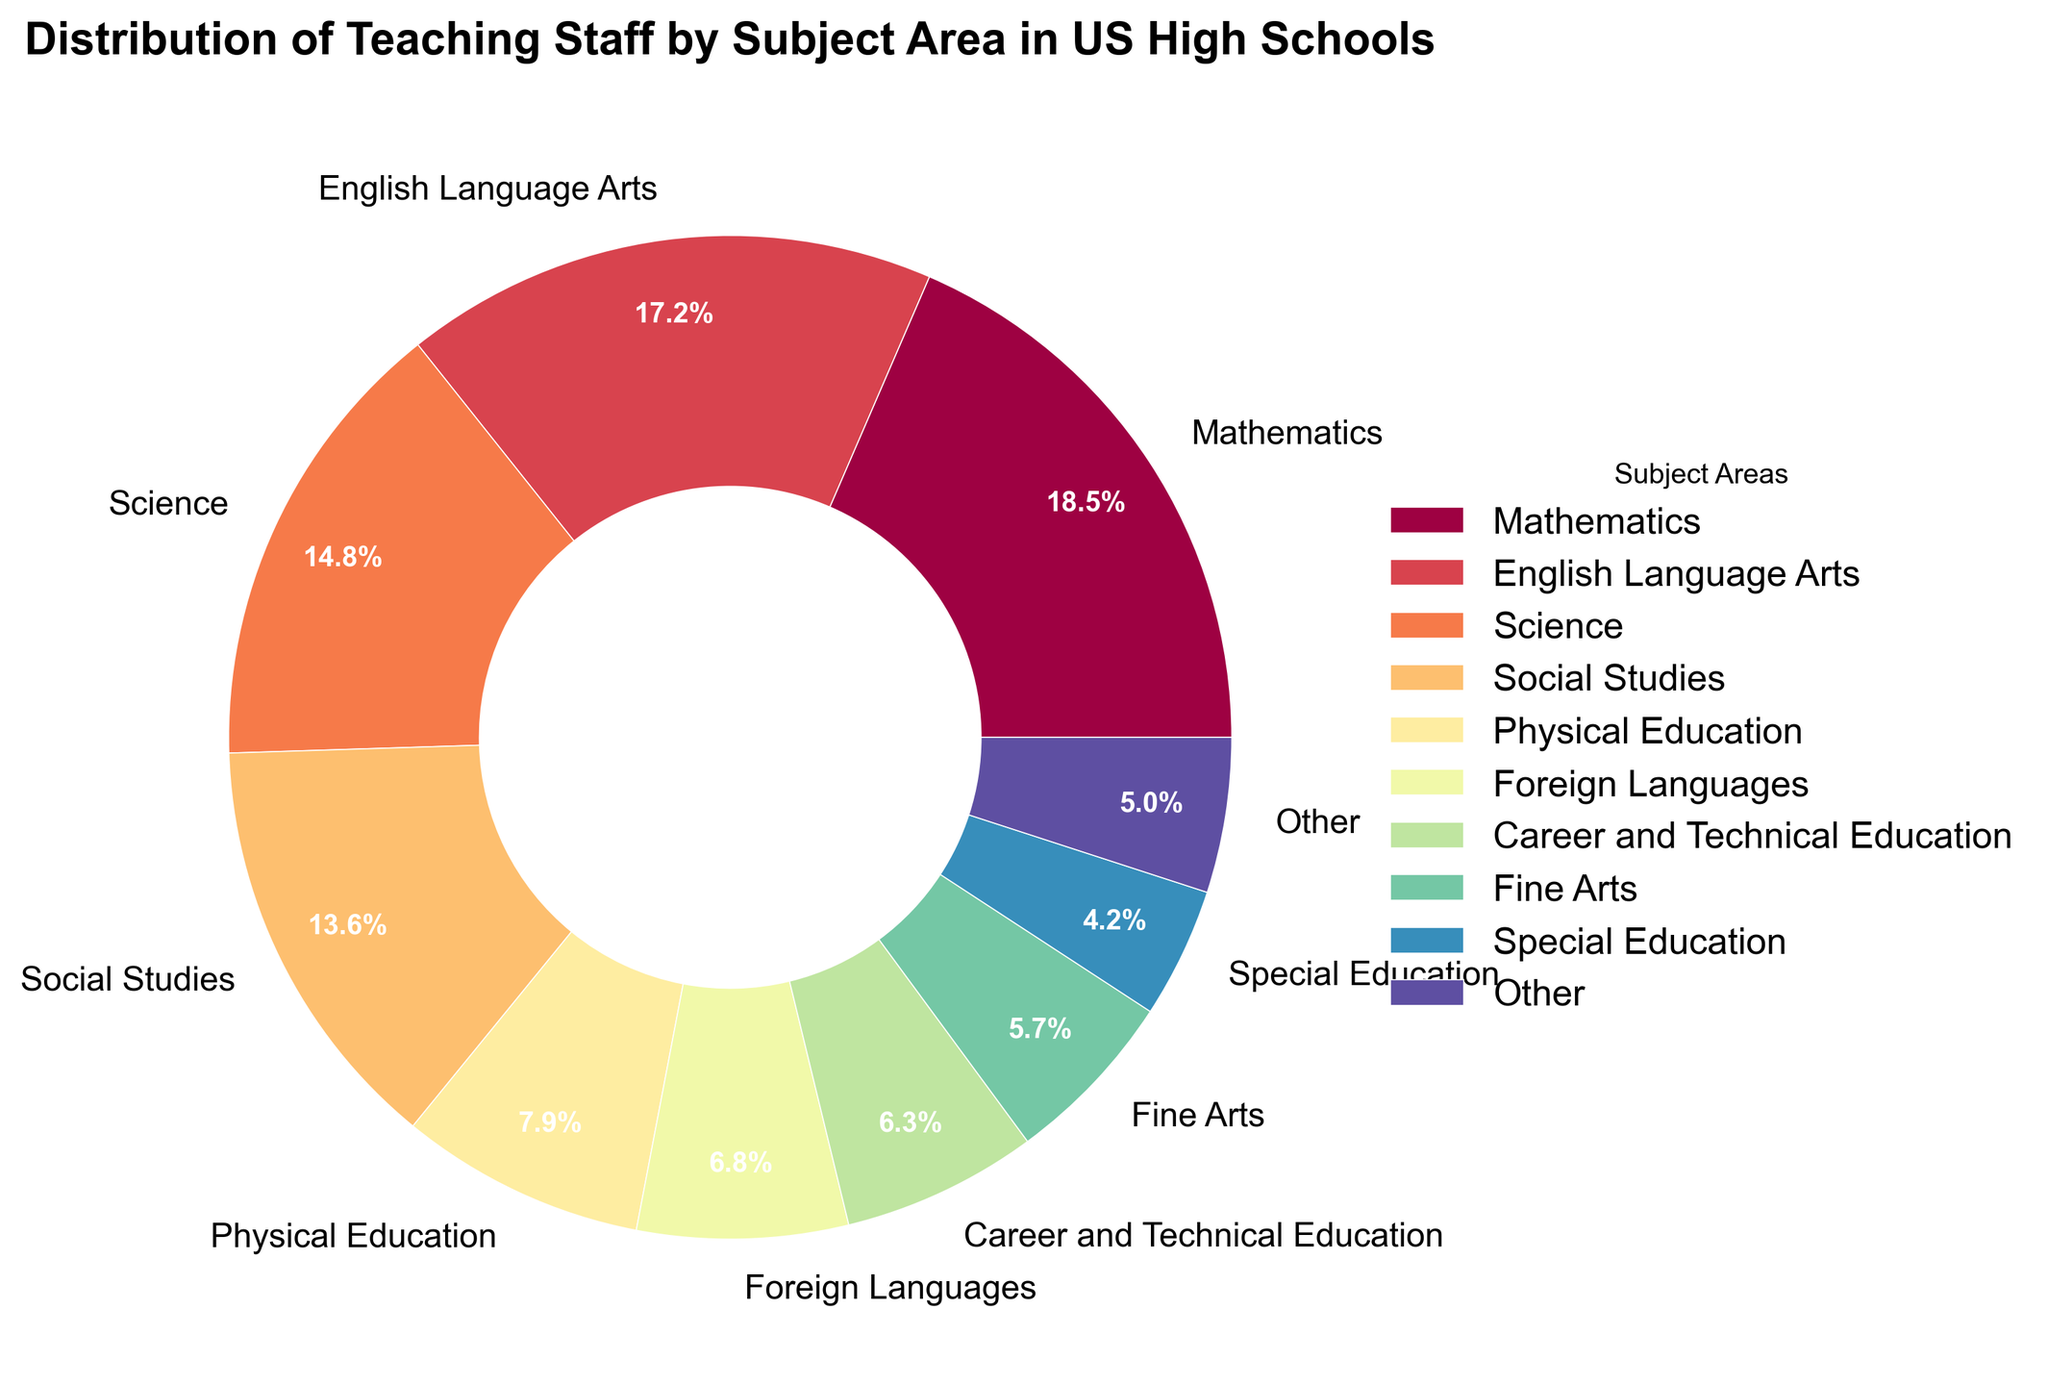Which subject area has the highest percentage of teaching staff? The subject area with the largest segment in the pie chart is Mathematics at 18.5%.
Answer: Mathematics What is the combined percentage of teaching staff for English Language Arts and Social Studies? Adding the percentages for English Language Arts (17.2%) and Social Studies (13.6%) yields 17.2% + 13.6% = 30.8%.
Answer: 30.8% How does the percentage of teaching staff for Science compare with Mathematics? Mathematics has a percentage of 18.5%, while Science has 14.8%. So, Mathematics has a higher percentage than Science by 18.5% - 14.8% = 3.7%.
Answer: Mathematics has 3.7% more Which subject areas are included in the "Other" category, and what is their combined percentage? The "Other" category includes subject areas with percentages less than 3%: Computer Science (2.8%), Health Education (1.4%), and STEM Electives (0.8%). Adding these gives 2.8% + 1.4% + 0.8% = 5.0%.
Answer: Computer Science, Health Education, STEM Electives, 5.0% What is the total percentage of teaching staff for Fine Arts, Special Education, and Physical Education? Adding the percentages for Fine Arts (5.7%), Special Education (4.2%), and Physical Education (7.9%) gives 5.7% + 4.2% + 7.9% = 17.8%.
Answer: 17.8% Which subject has a smaller teaching staff percentage: Foreign Languages or Career and Technical Education? Foreign Languages has 6.8%, while Career and Technical Education has 6.3%. Therefore, Career and Technical Education has a smaller teaching staff percentage.
Answer: Career and Technical Education What is the median percentage of teaching staff for the main subject areas shown (excluding "Other")? The main subjects are ordered by percentage: 18.5%, 17.2%, 14.8%, 13.6%, 7.9%, 6.8%, 6.3%, 5.7%, 4.2%. The median is the middle value of these ordered percentages, which is 7.9%.
Answer: 7.9% If the "Other" category were broken down, would Computer Science be visible independently? The threshold for inclusion as an individual category is 3%, and Computer Science has 2.8%, which is below this threshold; hence, it would not be individually visible.
Answer: No, it would not 